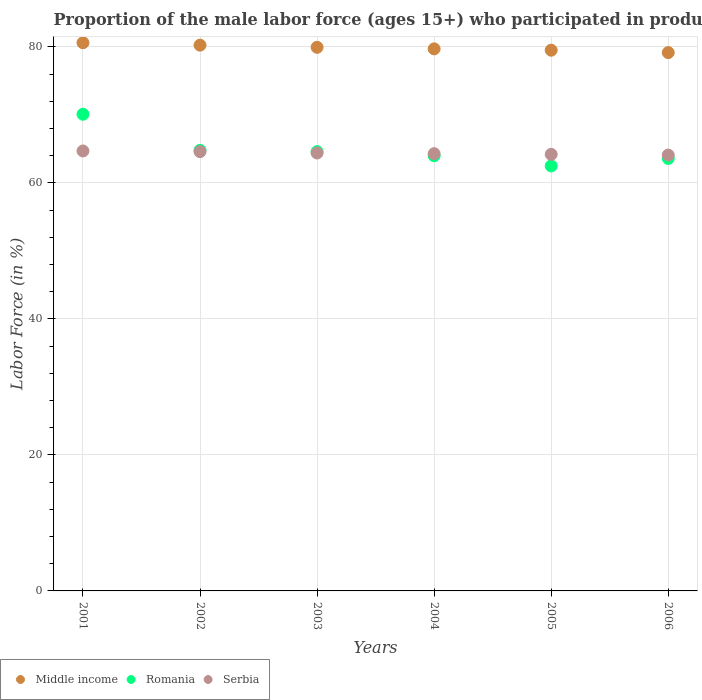Is the number of dotlines equal to the number of legend labels?
Ensure brevity in your answer.  Yes. What is the proportion of the male labor force who participated in production in Middle income in 2004?
Provide a short and direct response. 79.72. Across all years, what is the maximum proportion of the male labor force who participated in production in Middle income?
Make the answer very short. 80.62. Across all years, what is the minimum proportion of the male labor force who participated in production in Romania?
Offer a very short reply. 62.5. In which year was the proportion of the male labor force who participated in production in Serbia minimum?
Provide a short and direct response. 2006. What is the total proportion of the male labor force who participated in production in Middle income in the graph?
Your response must be concise. 479.22. What is the difference between the proportion of the male labor force who participated in production in Middle income in 2005 and that in 2006?
Your answer should be compact. 0.35. What is the difference between the proportion of the male labor force who participated in production in Romania in 2002 and the proportion of the male labor force who participated in production in Middle income in 2003?
Provide a short and direct response. -15.14. What is the average proportion of the male labor force who participated in production in Middle income per year?
Offer a terse response. 79.87. In the year 2006, what is the difference between the proportion of the male labor force who participated in production in Middle income and proportion of the male labor force who participated in production in Romania?
Keep it short and to the point. 15.57. In how many years, is the proportion of the male labor force who participated in production in Romania greater than 52 %?
Your answer should be compact. 6. What is the ratio of the proportion of the male labor force who participated in production in Serbia in 2004 to that in 2005?
Your answer should be very brief. 1. What is the difference between the highest and the second highest proportion of the male labor force who participated in production in Serbia?
Offer a very short reply. 0.1. What is the difference between the highest and the lowest proportion of the male labor force who participated in production in Romania?
Your response must be concise. 7.6. In how many years, is the proportion of the male labor force who participated in production in Middle income greater than the average proportion of the male labor force who participated in production in Middle income taken over all years?
Provide a short and direct response. 3. Does the proportion of the male labor force who participated in production in Middle income monotonically increase over the years?
Your response must be concise. No. Is the proportion of the male labor force who participated in production in Romania strictly less than the proportion of the male labor force who participated in production in Serbia over the years?
Give a very brief answer. No. How many dotlines are there?
Your answer should be compact. 3. How many years are there in the graph?
Your answer should be very brief. 6. What is the difference between two consecutive major ticks on the Y-axis?
Provide a short and direct response. 20. Does the graph contain grids?
Your answer should be compact. Yes. Where does the legend appear in the graph?
Offer a terse response. Bottom left. How many legend labels are there?
Keep it short and to the point. 3. What is the title of the graph?
Give a very brief answer. Proportion of the male labor force (ages 15+) who participated in production. What is the label or title of the X-axis?
Your response must be concise. Years. What is the label or title of the Y-axis?
Give a very brief answer. Labor Force (in %). What is the Labor Force (in %) of Middle income in 2001?
Provide a succinct answer. 80.62. What is the Labor Force (in %) in Romania in 2001?
Keep it short and to the point. 70.1. What is the Labor Force (in %) of Serbia in 2001?
Give a very brief answer. 64.7. What is the Labor Force (in %) in Middle income in 2002?
Offer a very short reply. 80.26. What is the Labor Force (in %) of Romania in 2002?
Offer a terse response. 64.8. What is the Labor Force (in %) of Serbia in 2002?
Ensure brevity in your answer.  64.6. What is the Labor Force (in %) in Middle income in 2003?
Offer a terse response. 79.94. What is the Labor Force (in %) of Romania in 2003?
Offer a terse response. 64.6. What is the Labor Force (in %) of Serbia in 2003?
Provide a succinct answer. 64.4. What is the Labor Force (in %) of Middle income in 2004?
Your answer should be compact. 79.72. What is the Labor Force (in %) in Romania in 2004?
Provide a succinct answer. 64. What is the Labor Force (in %) in Serbia in 2004?
Offer a very short reply. 64.3. What is the Labor Force (in %) of Middle income in 2005?
Ensure brevity in your answer.  79.52. What is the Labor Force (in %) in Romania in 2005?
Your answer should be compact. 62.5. What is the Labor Force (in %) in Serbia in 2005?
Offer a terse response. 64.2. What is the Labor Force (in %) of Middle income in 2006?
Offer a terse response. 79.17. What is the Labor Force (in %) in Romania in 2006?
Make the answer very short. 63.6. What is the Labor Force (in %) of Serbia in 2006?
Your answer should be very brief. 64.1. Across all years, what is the maximum Labor Force (in %) of Middle income?
Provide a short and direct response. 80.62. Across all years, what is the maximum Labor Force (in %) in Romania?
Offer a very short reply. 70.1. Across all years, what is the maximum Labor Force (in %) in Serbia?
Make the answer very short. 64.7. Across all years, what is the minimum Labor Force (in %) in Middle income?
Offer a very short reply. 79.17. Across all years, what is the minimum Labor Force (in %) of Romania?
Your response must be concise. 62.5. Across all years, what is the minimum Labor Force (in %) of Serbia?
Your response must be concise. 64.1. What is the total Labor Force (in %) of Middle income in the graph?
Offer a very short reply. 479.22. What is the total Labor Force (in %) in Romania in the graph?
Provide a succinct answer. 389.6. What is the total Labor Force (in %) in Serbia in the graph?
Keep it short and to the point. 386.3. What is the difference between the Labor Force (in %) of Middle income in 2001 and that in 2002?
Provide a short and direct response. 0.36. What is the difference between the Labor Force (in %) of Romania in 2001 and that in 2002?
Ensure brevity in your answer.  5.3. What is the difference between the Labor Force (in %) in Serbia in 2001 and that in 2002?
Keep it short and to the point. 0.1. What is the difference between the Labor Force (in %) in Middle income in 2001 and that in 2003?
Offer a very short reply. 0.67. What is the difference between the Labor Force (in %) of Romania in 2001 and that in 2003?
Your answer should be compact. 5.5. What is the difference between the Labor Force (in %) in Serbia in 2001 and that in 2003?
Your answer should be compact. 0.3. What is the difference between the Labor Force (in %) in Middle income in 2001 and that in 2004?
Offer a terse response. 0.9. What is the difference between the Labor Force (in %) in Romania in 2001 and that in 2004?
Provide a short and direct response. 6.1. What is the difference between the Labor Force (in %) of Middle income in 2001 and that in 2005?
Provide a short and direct response. 1.1. What is the difference between the Labor Force (in %) of Serbia in 2001 and that in 2005?
Ensure brevity in your answer.  0.5. What is the difference between the Labor Force (in %) in Middle income in 2001 and that in 2006?
Your answer should be compact. 1.45. What is the difference between the Labor Force (in %) of Romania in 2001 and that in 2006?
Your answer should be very brief. 6.5. What is the difference between the Labor Force (in %) of Serbia in 2001 and that in 2006?
Provide a succinct answer. 0.6. What is the difference between the Labor Force (in %) of Middle income in 2002 and that in 2003?
Offer a terse response. 0.32. What is the difference between the Labor Force (in %) in Middle income in 2002 and that in 2004?
Your response must be concise. 0.54. What is the difference between the Labor Force (in %) of Romania in 2002 and that in 2004?
Provide a short and direct response. 0.8. What is the difference between the Labor Force (in %) in Middle income in 2002 and that in 2005?
Provide a short and direct response. 0.74. What is the difference between the Labor Force (in %) of Romania in 2002 and that in 2005?
Keep it short and to the point. 2.3. What is the difference between the Labor Force (in %) of Middle income in 2002 and that in 2006?
Offer a very short reply. 1.09. What is the difference between the Labor Force (in %) of Middle income in 2003 and that in 2004?
Give a very brief answer. 0.23. What is the difference between the Labor Force (in %) of Romania in 2003 and that in 2004?
Offer a very short reply. 0.6. What is the difference between the Labor Force (in %) in Serbia in 2003 and that in 2004?
Provide a short and direct response. 0.1. What is the difference between the Labor Force (in %) in Middle income in 2003 and that in 2005?
Provide a succinct answer. 0.43. What is the difference between the Labor Force (in %) in Serbia in 2003 and that in 2005?
Offer a terse response. 0.2. What is the difference between the Labor Force (in %) in Middle income in 2003 and that in 2006?
Offer a terse response. 0.77. What is the difference between the Labor Force (in %) in Romania in 2003 and that in 2006?
Give a very brief answer. 1. What is the difference between the Labor Force (in %) of Middle income in 2004 and that in 2005?
Offer a terse response. 0.2. What is the difference between the Labor Force (in %) in Romania in 2004 and that in 2005?
Keep it short and to the point. 1.5. What is the difference between the Labor Force (in %) in Middle income in 2004 and that in 2006?
Provide a succinct answer. 0.55. What is the difference between the Labor Force (in %) in Serbia in 2004 and that in 2006?
Ensure brevity in your answer.  0.2. What is the difference between the Labor Force (in %) in Middle income in 2005 and that in 2006?
Provide a succinct answer. 0.35. What is the difference between the Labor Force (in %) in Romania in 2005 and that in 2006?
Make the answer very short. -1.1. What is the difference between the Labor Force (in %) in Middle income in 2001 and the Labor Force (in %) in Romania in 2002?
Offer a very short reply. 15.82. What is the difference between the Labor Force (in %) of Middle income in 2001 and the Labor Force (in %) of Serbia in 2002?
Offer a very short reply. 16.02. What is the difference between the Labor Force (in %) in Middle income in 2001 and the Labor Force (in %) in Romania in 2003?
Give a very brief answer. 16.02. What is the difference between the Labor Force (in %) of Middle income in 2001 and the Labor Force (in %) of Serbia in 2003?
Provide a succinct answer. 16.22. What is the difference between the Labor Force (in %) in Middle income in 2001 and the Labor Force (in %) in Romania in 2004?
Give a very brief answer. 16.62. What is the difference between the Labor Force (in %) in Middle income in 2001 and the Labor Force (in %) in Serbia in 2004?
Keep it short and to the point. 16.32. What is the difference between the Labor Force (in %) of Romania in 2001 and the Labor Force (in %) of Serbia in 2004?
Your response must be concise. 5.8. What is the difference between the Labor Force (in %) of Middle income in 2001 and the Labor Force (in %) of Romania in 2005?
Give a very brief answer. 18.12. What is the difference between the Labor Force (in %) in Middle income in 2001 and the Labor Force (in %) in Serbia in 2005?
Your answer should be compact. 16.42. What is the difference between the Labor Force (in %) of Middle income in 2001 and the Labor Force (in %) of Romania in 2006?
Your answer should be compact. 17.02. What is the difference between the Labor Force (in %) of Middle income in 2001 and the Labor Force (in %) of Serbia in 2006?
Give a very brief answer. 16.52. What is the difference between the Labor Force (in %) in Romania in 2001 and the Labor Force (in %) in Serbia in 2006?
Provide a succinct answer. 6. What is the difference between the Labor Force (in %) of Middle income in 2002 and the Labor Force (in %) of Romania in 2003?
Provide a succinct answer. 15.66. What is the difference between the Labor Force (in %) of Middle income in 2002 and the Labor Force (in %) of Serbia in 2003?
Keep it short and to the point. 15.86. What is the difference between the Labor Force (in %) in Romania in 2002 and the Labor Force (in %) in Serbia in 2003?
Offer a terse response. 0.4. What is the difference between the Labor Force (in %) in Middle income in 2002 and the Labor Force (in %) in Romania in 2004?
Give a very brief answer. 16.26. What is the difference between the Labor Force (in %) in Middle income in 2002 and the Labor Force (in %) in Serbia in 2004?
Ensure brevity in your answer.  15.96. What is the difference between the Labor Force (in %) in Romania in 2002 and the Labor Force (in %) in Serbia in 2004?
Offer a very short reply. 0.5. What is the difference between the Labor Force (in %) of Middle income in 2002 and the Labor Force (in %) of Romania in 2005?
Ensure brevity in your answer.  17.76. What is the difference between the Labor Force (in %) in Middle income in 2002 and the Labor Force (in %) in Serbia in 2005?
Keep it short and to the point. 16.06. What is the difference between the Labor Force (in %) in Middle income in 2002 and the Labor Force (in %) in Romania in 2006?
Your answer should be compact. 16.66. What is the difference between the Labor Force (in %) in Middle income in 2002 and the Labor Force (in %) in Serbia in 2006?
Make the answer very short. 16.16. What is the difference between the Labor Force (in %) in Middle income in 2003 and the Labor Force (in %) in Romania in 2004?
Make the answer very short. 15.94. What is the difference between the Labor Force (in %) in Middle income in 2003 and the Labor Force (in %) in Serbia in 2004?
Your answer should be very brief. 15.64. What is the difference between the Labor Force (in %) of Romania in 2003 and the Labor Force (in %) of Serbia in 2004?
Your response must be concise. 0.3. What is the difference between the Labor Force (in %) of Middle income in 2003 and the Labor Force (in %) of Romania in 2005?
Provide a short and direct response. 17.44. What is the difference between the Labor Force (in %) in Middle income in 2003 and the Labor Force (in %) in Serbia in 2005?
Ensure brevity in your answer.  15.74. What is the difference between the Labor Force (in %) of Middle income in 2003 and the Labor Force (in %) of Romania in 2006?
Your answer should be very brief. 16.34. What is the difference between the Labor Force (in %) in Middle income in 2003 and the Labor Force (in %) in Serbia in 2006?
Your response must be concise. 15.84. What is the difference between the Labor Force (in %) in Romania in 2003 and the Labor Force (in %) in Serbia in 2006?
Your response must be concise. 0.5. What is the difference between the Labor Force (in %) in Middle income in 2004 and the Labor Force (in %) in Romania in 2005?
Provide a short and direct response. 17.22. What is the difference between the Labor Force (in %) in Middle income in 2004 and the Labor Force (in %) in Serbia in 2005?
Offer a terse response. 15.52. What is the difference between the Labor Force (in %) of Middle income in 2004 and the Labor Force (in %) of Romania in 2006?
Provide a succinct answer. 16.12. What is the difference between the Labor Force (in %) of Middle income in 2004 and the Labor Force (in %) of Serbia in 2006?
Your response must be concise. 15.62. What is the difference between the Labor Force (in %) of Romania in 2004 and the Labor Force (in %) of Serbia in 2006?
Provide a short and direct response. -0.1. What is the difference between the Labor Force (in %) of Middle income in 2005 and the Labor Force (in %) of Romania in 2006?
Provide a short and direct response. 15.92. What is the difference between the Labor Force (in %) in Middle income in 2005 and the Labor Force (in %) in Serbia in 2006?
Give a very brief answer. 15.42. What is the difference between the Labor Force (in %) of Romania in 2005 and the Labor Force (in %) of Serbia in 2006?
Your response must be concise. -1.6. What is the average Labor Force (in %) in Middle income per year?
Offer a terse response. 79.87. What is the average Labor Force (in %) of Romania per year?
Offer a very short reply. 64.93. What is the average Labor Force (in %) of Serbia per year?
Your answer should be compact. 64.38. In the year 2001, what is the difference between the Labor Force (in %) in Middle income and Labor Force (in %) in Romania?
Make the answer very short. 10.52. In the year 2001, what is the difference between the Labor Force (in %) in Middle income and Labor Force (in %) in Serbia?
Provide a succinct answer. 15.92. In the year 2001, what is the difference between the Labor Force (in %) in Romania and Labor Force (in %) in Serbia?
Provide a succinct answer. 5.4. In the year 2002, what is the difference between the Labor Force (in %) of Middle income and Labor Force (in %) of Romania?
Offer a very short reply. 15.46. In the year 2002, what is the difference between the Labor Force (in %) of Middle income and Labor Force (in %) of Serbia?
Your answer should be compact. 15.66. In the year 2003, what is the difference between the Labor Force (in %) of Middle income and Labor Force (in %) of Romania?
Your answer should be compact. 15.34. In the year 2003, what is the difference between the Labor Force (in %) of Middle income and Labor Force (in %) of Serbia?
Ensure brevity in your answer.  15.54. In the year 2004, what is the difference between the Labor Force (in %) in Middle income and Labor Force (in %) in Romania?
Your response must be concise. 15.72. In the year 2004, what is the difference between the Labor Force (in %) in Middle income and Labor Force (in %) in Serbia?
Offer a very short reply. 15.42. In the year 2004, what is the difference between the Labor Force (in %) in Romania and Labor Force (in %) in Serbia?
Ensure brevity in your answer.  -0.3. In the year 2005, what is the difference between the Labor Force (in %) in Middle income and Labor Force (in %) in Romania?
Your answer should be very brief. 17.02. In the year 2005, what is the difference between the Labor Force (in %) in Middle income and Labor Force (in %) in Serbia?
Make the answer very short. 15.32. In the year 2005, what is the difference between the Labor Force (in %) in Romania and Labor Force (in %) in Serbia?
Offer a very short reply. -1.7. In the year 2006, what is the difference between the Labor Force (in %) of Middle income and Labor Force (in %) of Romania?
Ensure brevity in your answer.  15.57. In the year 2006, what is the difference between the Labor Force (in %) of Middle income and Labor Force (in %) of Serbia?
Make the answer very short. 15.07. In the year 2006, what is the difference between the Labor Force (in %) in Romania and Labor Force (in %) in Serbia?
Offer a terse response. -0.5. What is the ratio of the Labor Force (in %) of Middle income in 2001 to that in 2002?
Offer a terse response. 1. What is the ratio of the Labor Force (in %) of Romania in 2001 to that in 2002?
Your answer should be compact. 1.08. What is the ratio of the Labor Force (in %) in Serbia in 2001 to that in 2002?
Give a very brief answer. 1. What is the ratio of the Labor Force (in %) in Middle income in 2001 to that in 2003?
Your response must be concise. 1.01. What is the ratio of the Labor Force (in %) of Romania in 2001 to that in 2003?
Give a very brief answer. 1.09. What is the ratio of the Labor Force (in %) in Serbia in 2001 to that in 2003?
Provide a succinct answer. 1. What is the ratio of the Labor Force (in %) of Middle income in 2001 to that in 2004?
Ensure brevity in your answer.  1.01. What is the ratio of the Labor Force (in %) in Romania in 2001 to that in 2004?
Your response must be concise. 1.1. What is the ratio of the Labor Force (in %) of Serbia in 2001 to that in 2004?
Your response must be concise. 1.01. What is the ratio of the Labor Force (in %) of Middle income in 2001 to that in 2005?
Your answer should be very brief. 1.01. What is the ratio of the Labor Force (in %) of Romania in 2001 to that in 2005?
Make the answer very short. 1.12. What is the ratio of the Labor Force (in %) in Serbia in 2001 to that in 2005?
Keep it short and to the point. 1.01. What is the ratio of the Labor Force (in %) of Middle income in 2001 to that in 2006?
Give a very brief answer. 1.02. What is the ratio of the Labor Force (in %) in Romania in 2001 to that in 2006?
Your answer should be very brief. 1.1. What is the ratio of the Labor Force (in %) in Serbia in 2001 to that in 2006?
Offer a very short reply. 1.01. What is the ratio of the Labor Force (in %) in Romania in 2002 to that in 2003?
Make the answer very short. 1. What is the ratio of the Labor Force (in %) in Middle income in 2002 to that in 2004?
Keep it short and to the point. 1.01. What is the ratio of the Labor Force (in %) of Romania in 2002 to that in 2004?
Your answer should be very brief. 1.01. What is the ratio of the Labor Force (in %) of Middle income in 2002 to that in 2005?
Your answer should be compact. 1.01. What is the ratio of the Labor Force (in %) in Romania in 2002 to that in 2005?
Provide a succinct answer. 1.04. What is the ratio of the Labor Force (in %) in Middle income in 2002 to that in 2006?
Offer a terse response. 1.01. What is the ratio of the Labor Force (in %) in Romania in 2002 to that in 2006?
Make the answer very short. 1.02. What is the ratio of the Labor Force (in %) in Serbia in 2002 to that in 2006?
Provide a succinct answer. 1.01. What is the ratio of the Labor Force (in %) in Romania in 2003 to that in 2004?
Ensure brevity in your answer.  1.01. What is the ratio of the Labor Force (in %) of Serbia in 2003 to that in 2004?
Offer a very short reply. 1. What is the ratio of the Labor Force (in %) in Middle income in 2003 to that in 2005?
Provide a succinct answer. 1.01. What is the ratio of the Labor Force (in %) in Romania in 2003 to that in 2005?
Offer a very short reply. 1.03. What is the ratio of the Labor Force (in %) in Middle income in 2003 to that in 2006?
Your answer should be compact. 1.01. What is the ratio of the Labor Force (in %) of Romania in 2003 to that in 2006?
Make the answer very short. 1.02. What is the ratio of the Labor Force (in %) in Middle income in 2004 to that in 2005?
Make the answer very short. 1. What is the ratio of the Labor Force (in %) of Romania in 2004 to that in 2005?
Provide a short and direct response. 1.02. What is the ratio of the Labor Force (in %) of Serbia in 2004 to that in 2005?
Keep it short and to the point. 1. What is the ratio of the Labor Force (in %) of Middle income in 2004 to that in 2006?
Your response must be concise. 1.01. What is the ratio of the Labor Force (in %) in Romania in 2004 to that in 2006?
Keep it short and to the point. 1.01. What is the ratio of the Labor Force (in %) of Serbia in 2004 to that in 2006?
Give a very brief answer. 1. What is the ratio of the Labor Force (in %) of Romania in 2005 to that in 2006?
Give a very brief answer. 0.98. What is the difference between the highest and the second highest Labor Force (in %) in Middle income?
Provide a short and direct response. 0.36. What is the difference between the highest and the second highest Labor Force (in %) in Romania?
Give a very brief answer. 5.3. What is the difference between the highest and the lowest Labor Force (in %) in Middle income?
Give a very brief answer. 1.45. What is the difference between the highest and the lowest Labor Force (in %) in Romania?
Make the answer very short. 7.6. What is the difference between the highest and the lowest Labor Force (in %) of Serbia?
Give a very brief answer. 0.6. 